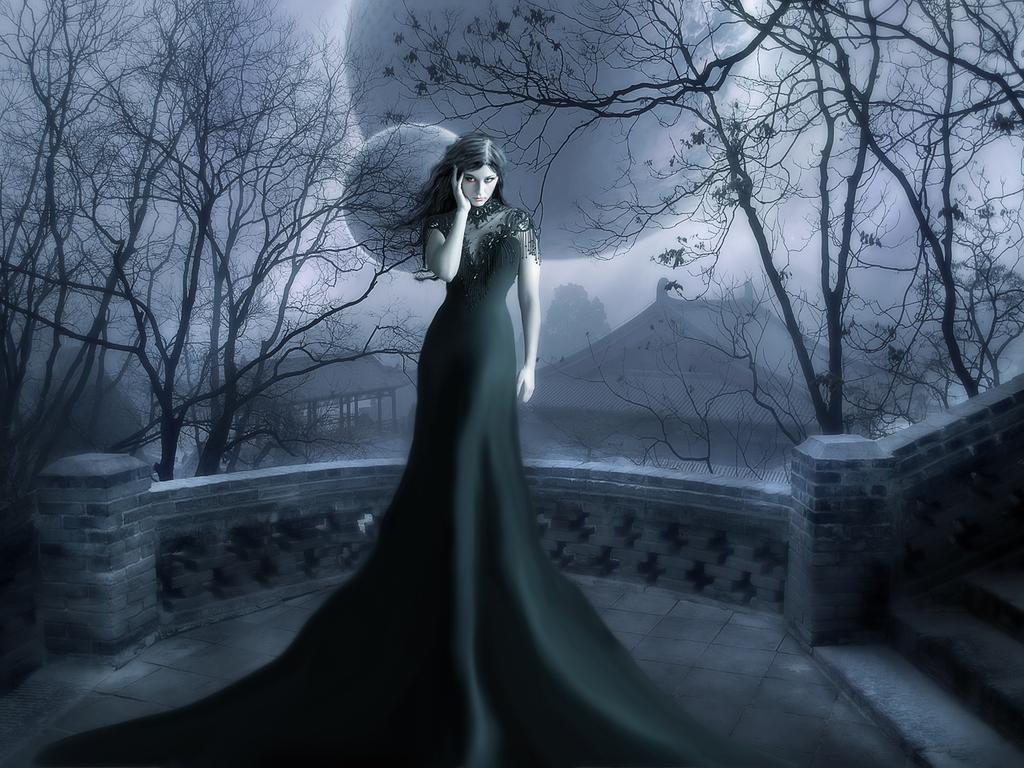What is the main subject of the image? The main subject of the image is a woman. What type of natural environment is visible in the image? There are trees in the image. What type of man-made structures are visible in the image? There are houses in the image. What type of sugar is being used to draw the shape in the image? There is no sugar or shape present in the image. What type of picture is being created with the sugar in the image? There is no sugar or picture being created in the image. 